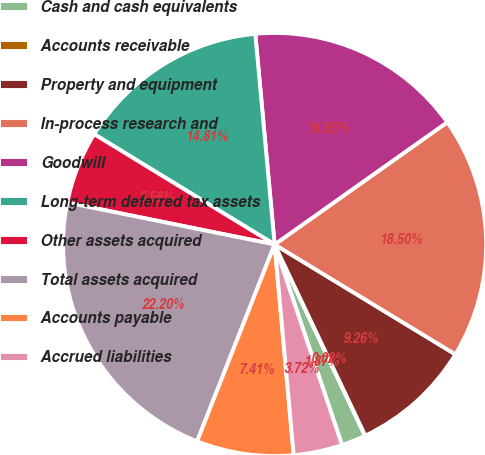Convert chart to OTSL. <chart><loc_0><loc_0><loc_500><loc_500><pie_chart><fcel>Cash and cash equivalents<fcel>Accounts receivable<fcel>Property and equipment<fcel>In-process research and<fcel>Goodwill<fcel>Long-term deferred tax assets<fcel>Other assets acquired<fcel>Total assets acquired<fcel>Accounts payable<fcel>Accrued liabilities<nl><fcel>1.87%<fcel>0.02%<fcel>9.26%<fcel>18.5%<fcel>16.65%<fcel>14.81%<fcel>5.56%<fcel>22.2%<fcel>7.41%<fcel>3.72%<nl></chart> 